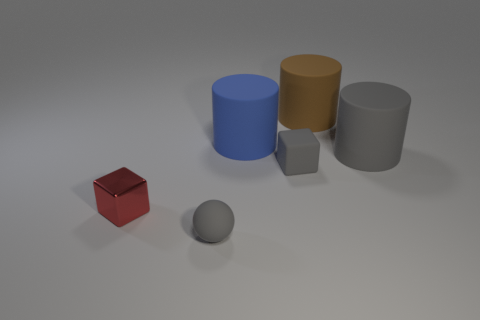There is a small ball; what number of cylinders are left of it?
Keep it short and to the point. 0. Are there any gray matte cylinders that have the same size as the ball?
Your answer should be compact. No. Is the shape of the small rubber thing on the left side of the blue matte cylinder the same as  the blue thing?
Provide a short and direct response. No. What is the color of the tiny matte sphere?
Give a very brief answer. Gray. The large rubber object that is the same color as the matte ball is what shape?
Keep it short and to the point. Cylinder. Is there a big red shiny cylinder?
Keep it short and to the point. No. The cube that is the same material as the big brown cylinder is what size?
Offer a very short reply. Small. The gray rubber object that is on the left side of the matte cylinder to the left of the thing that is behind the big blue cylinder is what shape?
Provide a succinct answer. Sphere. Are there the same number of gray matte things that are on the right side of the tiny matte cube and large purple rubber cylinders?
Make the answer very short. No. There is a cylinder that is the same color as the tiny sphere; what size is it?
Your answer should be very brief. Large. 